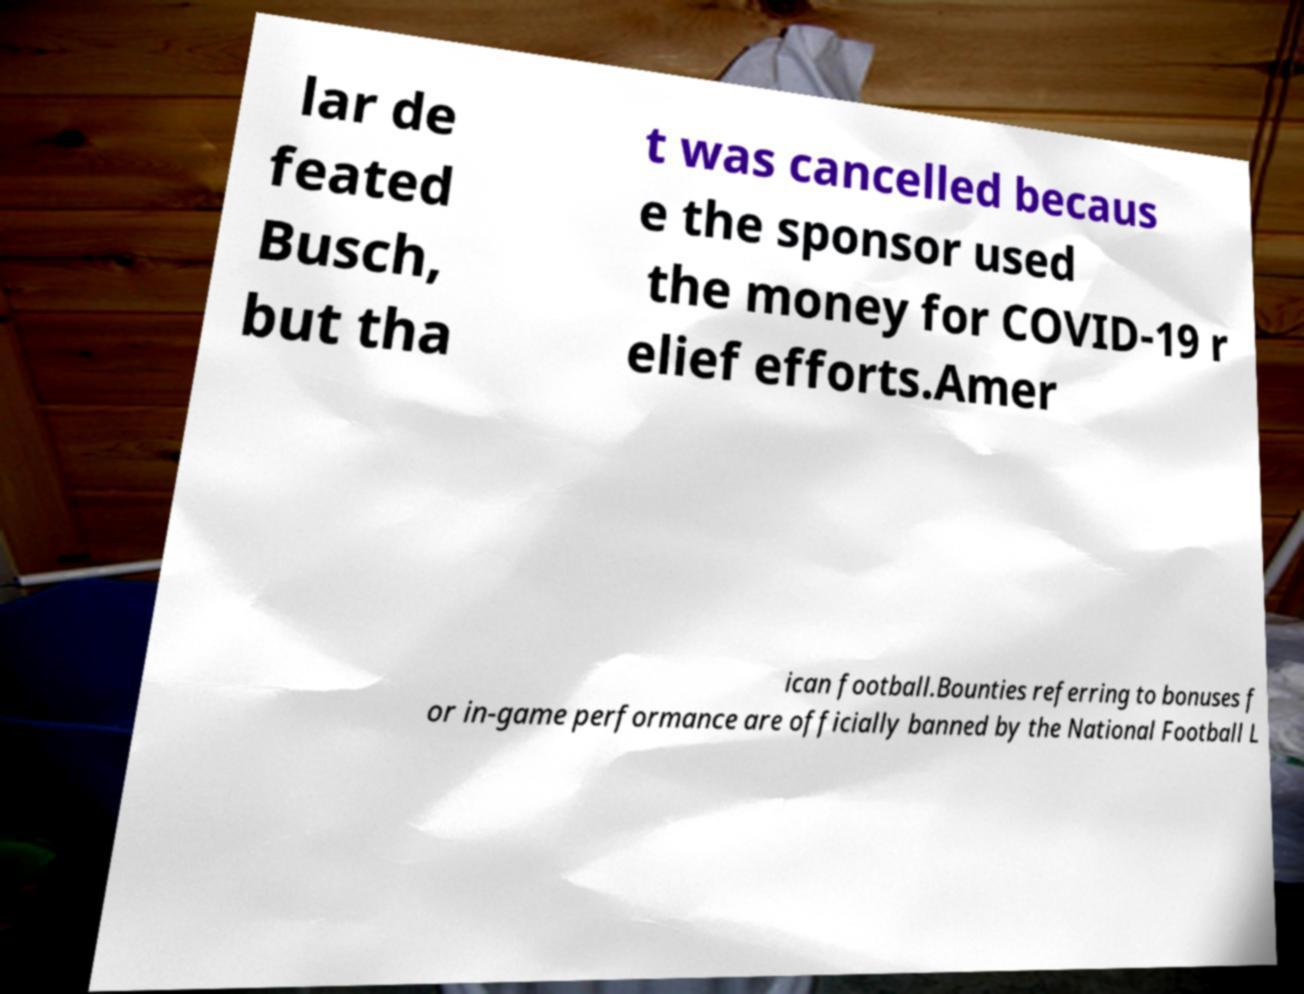Can you accurately transcribe the text from the provided image for me? lar de feated Busch, but tha t was cancelled becaus e the sponsor used the money for COVID-19 r elief efforts.Amer ican football.Bounties referring to bonuses f or in-game performance are officially banned by the National Football L 